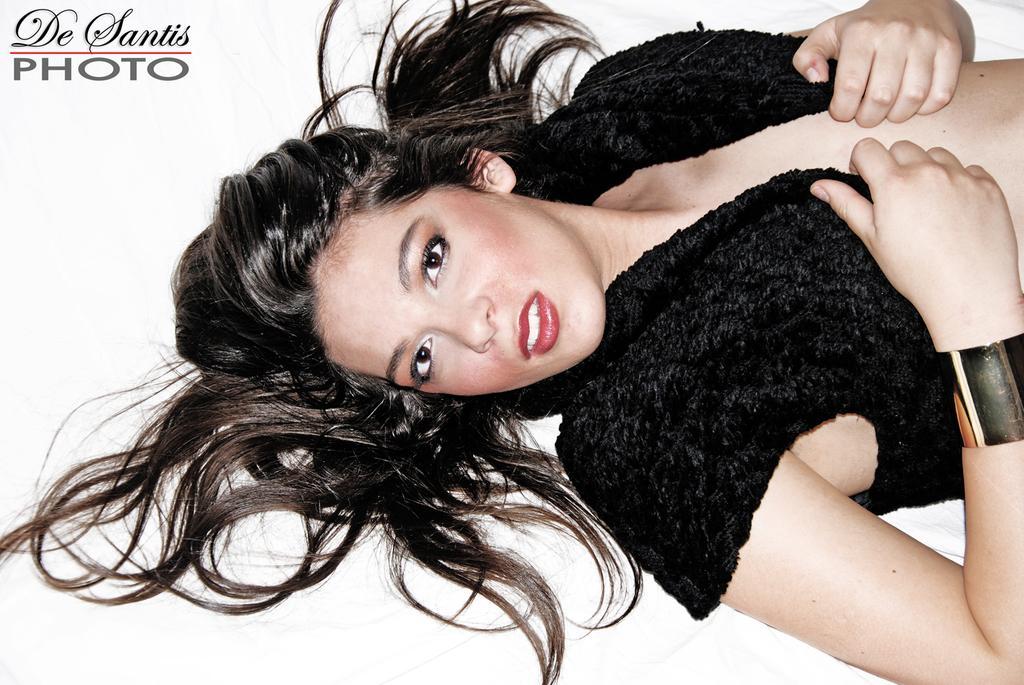Please provide a concise description of this image. In this image we can see a woman lying down on the surface. 